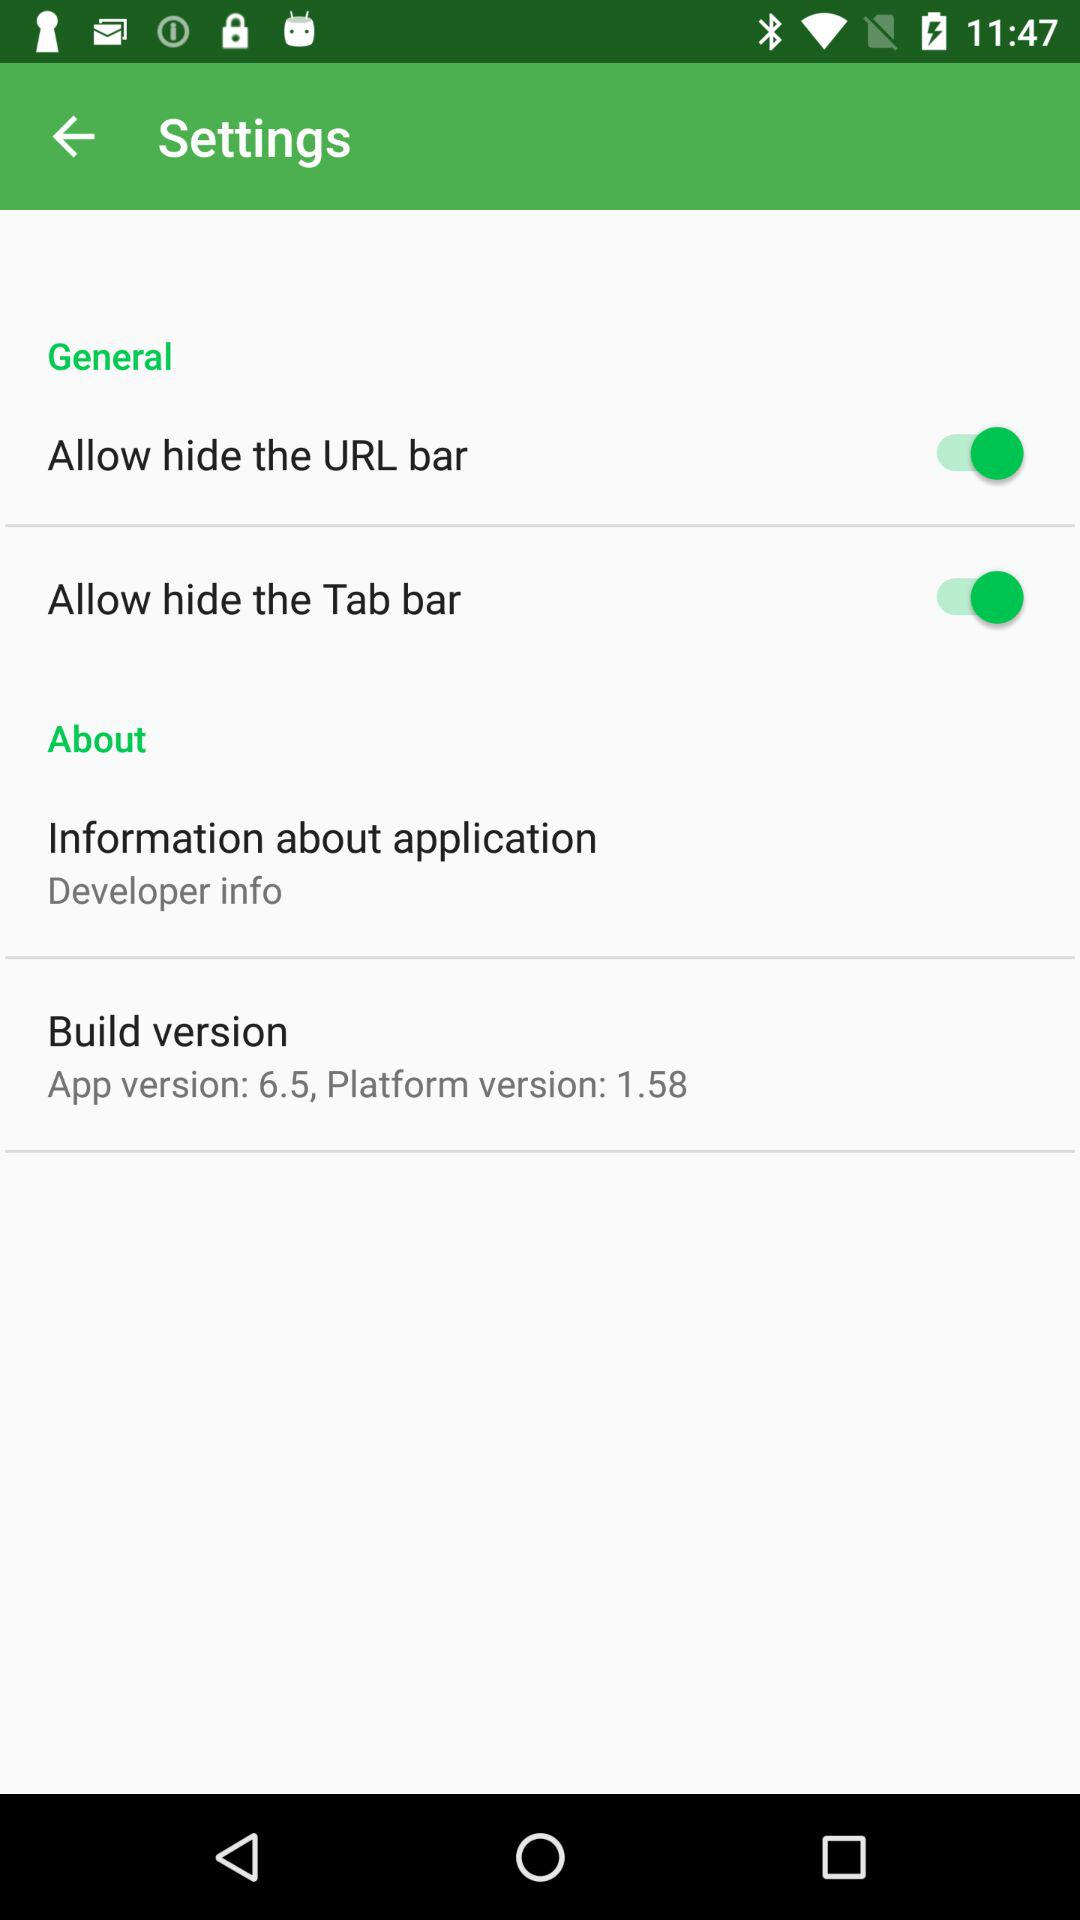What is the current app version? The current app version is 6.5. 